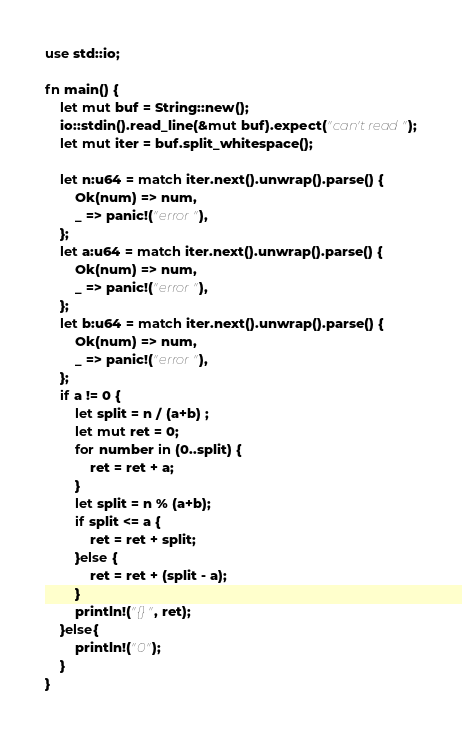<code> <loc_0><loc_0><loc_500><loc_500><_Rust_>use std::io;

fn main() {
	let mut buf = String::new();
	io::stdin().read_line(&mut buf).expect("can't read");
	let mut iter = buf.split_whitespace();
	
	let n:u64 = match iter.next().unwrap().parse() {
		Ok(num) => num,
		_ => panic!("error"),
	};
	let a:u64 = match iter.next().unwrap().parse() {
		Ok(num) => num,
		_ => panic!("error"),
	};
	let b:u64 = match iter.next().unwrap().parse() {
		Ok(num) => num,
		_ => panic!("error"),
	};
	if a != 0 {
		let split = n / (a+b) ;
		let mut ret = 0;
		for number in (0..split) {
			ret = ret + a;
		}
		let split = n % (a+b);
		if split <= a {
			ret = ret + split;
		}else {
			ret = ret + (split - a);
		}
		println!("{}", ret);
	}else{
		println!("0");
	}
}</code> 